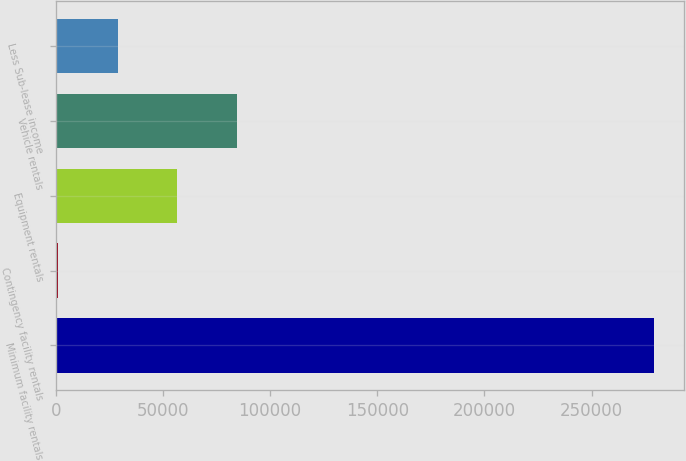Convert chart to OTSL. <chart><loc_0><loc_0><loc_500><loc_500><bar_chart><fcel>Minimum facility rentals<fcel>Contingency facility rentals<fcel>Equipment rentals<fcel>Vehicle rentals<fcel>Less Sub-lease income<nl><fcel>279099<fcel>1115<fcel>56711.8<fcel>84510.2<fcel>28913.4<nl></chart> 